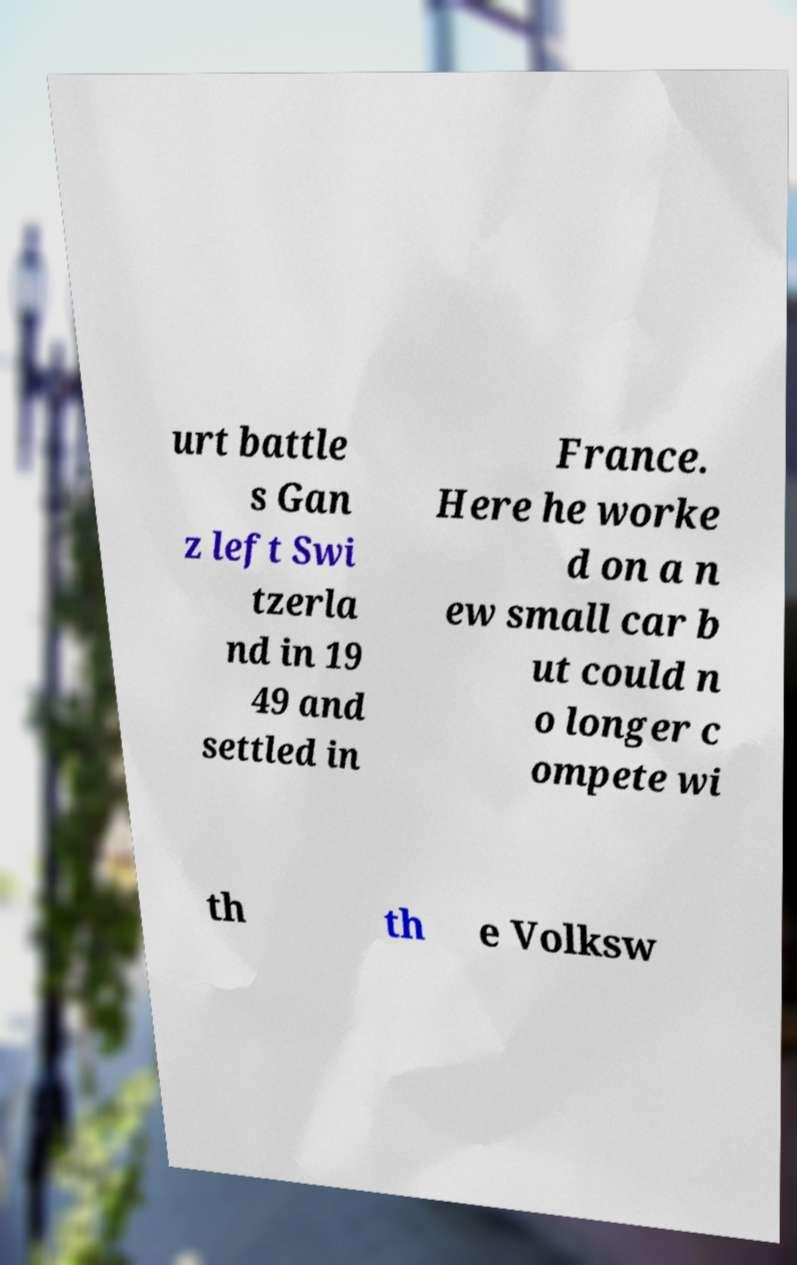For documentation purposes, I need the text within this image transcribed. Could you provide that? urt battle s Gan z left Swi tzerla nd in 19 49 and settled in France. Here he worke d on a n ew small car b ut could n o longer c ompete wi th th e Volksw 